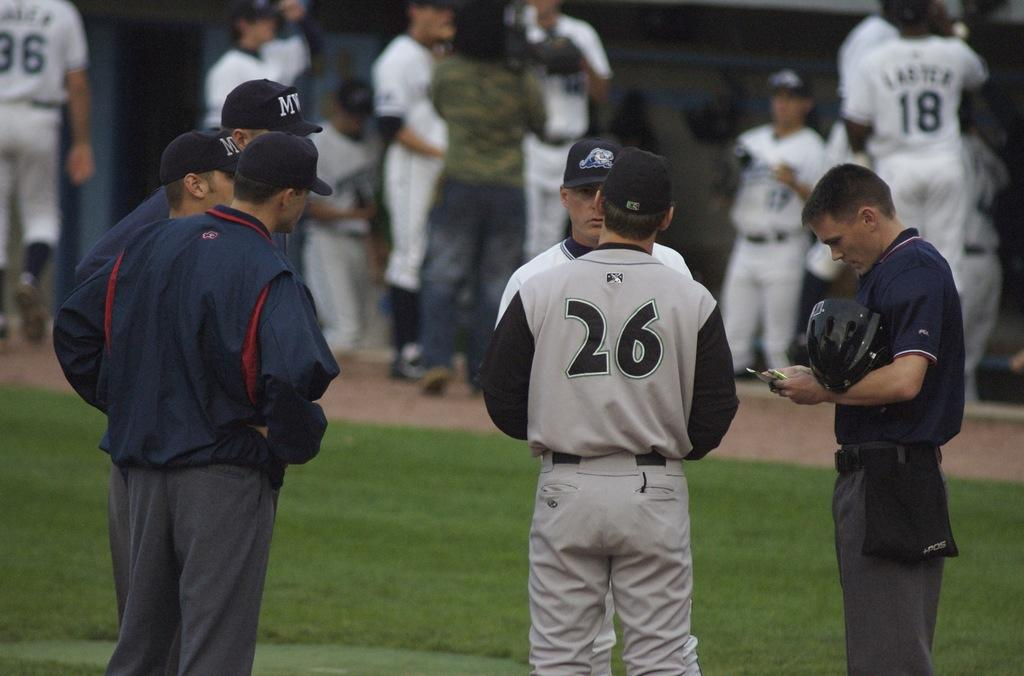<image>
Offer a succinct explanation of the picture presented. Baseball player number 26 is talking to another person and has his back to the camera. 